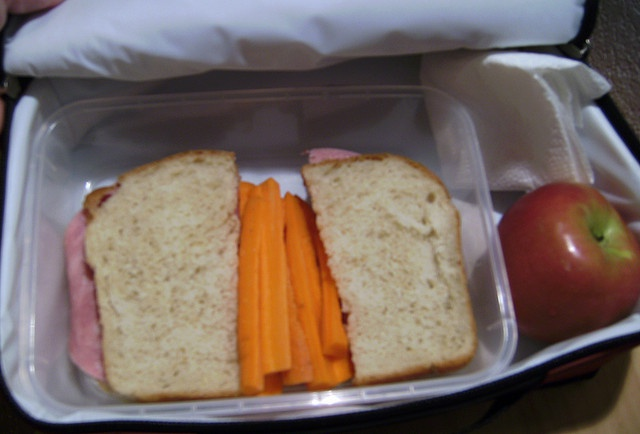Describe the objects in this image and their specific colors. I can see bowl in gray, darkgray, tan, and black tones, sandwich in gray, tan, and brown tones, sandwich in gray, tan, and maroon tones, apple in gray, maroon, black, and olive tones, and carrot in gray, red, and maroon tones in this image. 